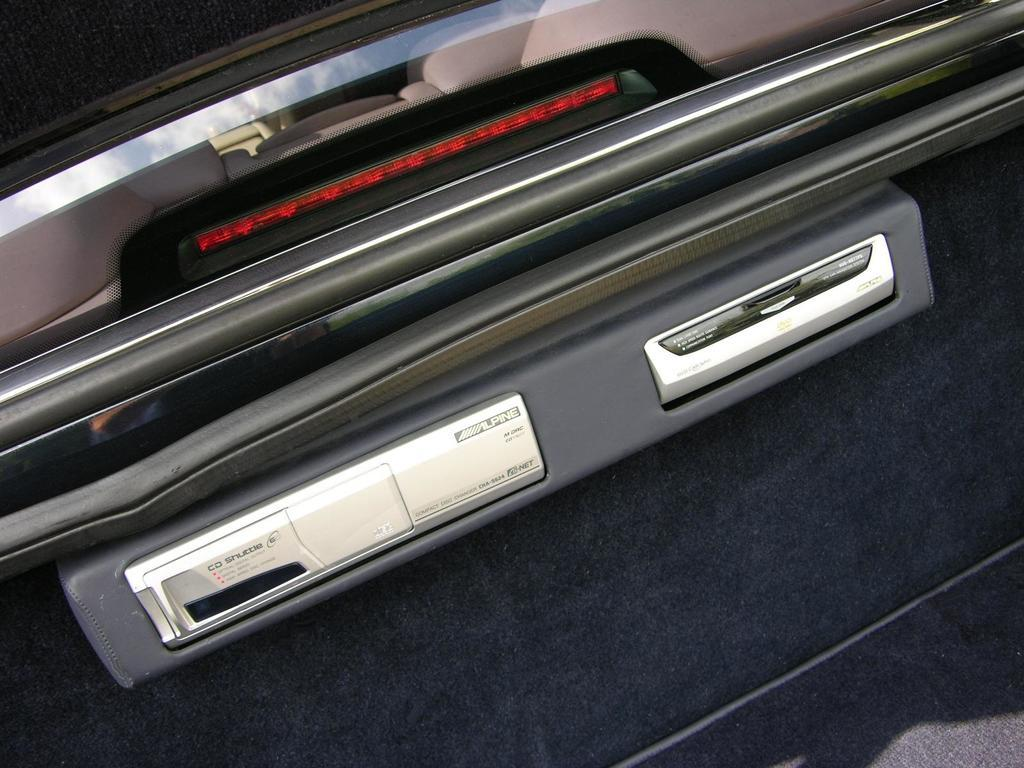What part of a car is shown in the image? The image shows the backside of a car. What specific feature can be seen on the car in the image? There is a brake light visible in the image. What type of control or function might be associated with the buttons in the image? The buttons in the image may be related to various car functions or features. What type of sail can be seen on the car in the image? There is no sail present on the car in the image. How does the car express its feelings of hate in the image? The car does not express any emotions, including hate, in the image. 